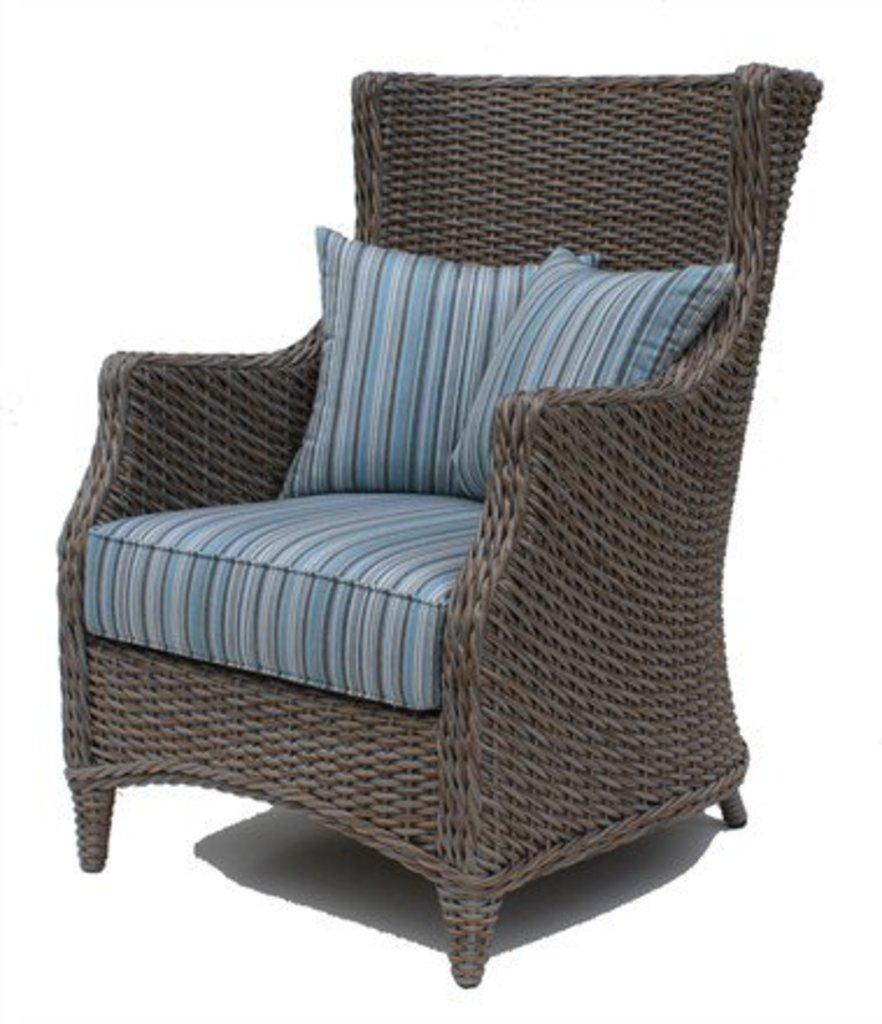What is the main object in the center of the image? There is a chair in the center of the image. What is placed on the chair? There are cushions placed on the chair. What type of rail can be seen in the image? There is no rail present in the image; it only features a chair with cushions. What kind of hall is depicted in the image? There is no hall depicted in the image; it only features a chair with cushions. 